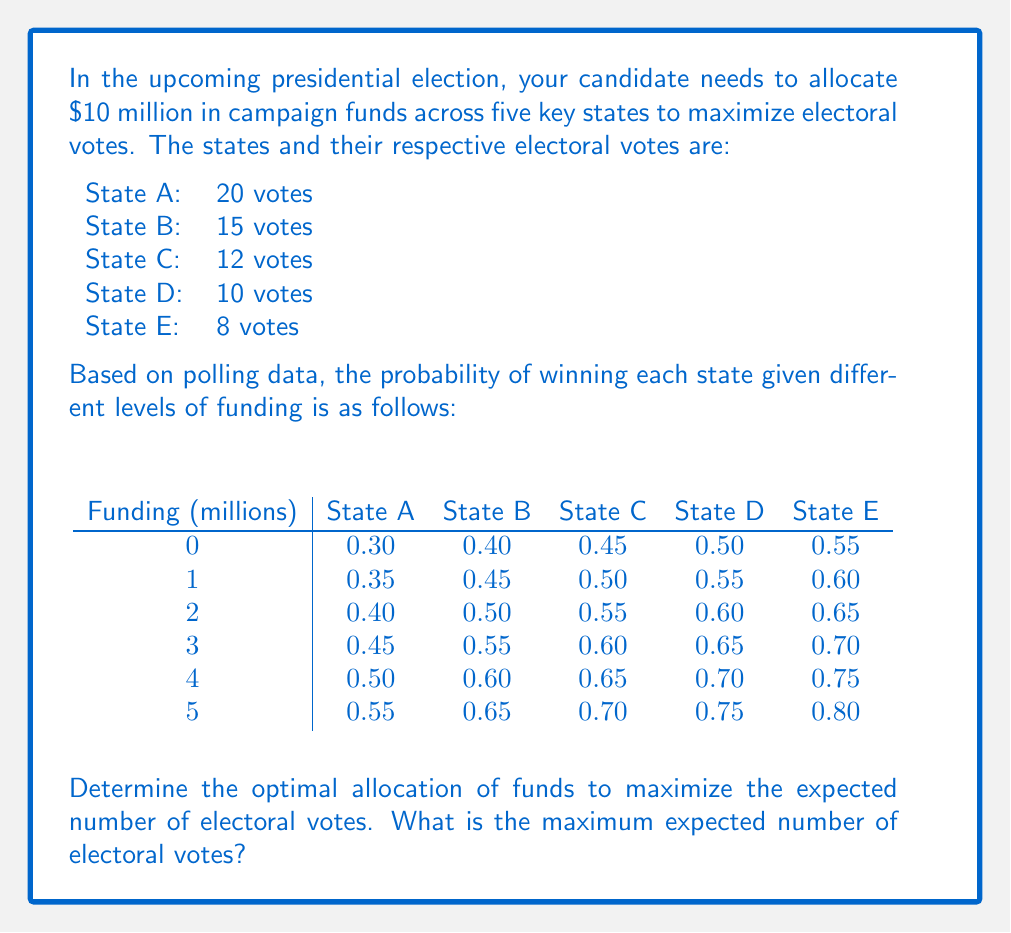Show me your answer to this math problem. To solve this optimization problem, we need to use the concept of expected value and find the combination that maximizes it. Let's approach this step-by-step:

1) First, calculate the expected electoral votes for each state at each funding level:

   Expected votes = (Probability of winning) × (Number of electoral votes)

   For example, for State A with $0 million: 0.30 × 20 = 6 expected votes

2) Create a table of expected votes for each state and funding level:

$$\begin{array}{c|ccccc}
\text{Funding (millions)} & \text{State A} & \text{State B} & \text{State C} & \text{State D} & \text{State E} \\
\hline
0 & 6.00 & 6.00 & 5.40 & 5.00 & 4.40 \\
1 & 7.00 & 6.75 & 6.00 & 5.50 & 4.80 \\
2 & 8.00 & 7.50 & 6.60 & 6.00 & 5.20 \\
3 & 9.00 & 8.25 & 7.20 & 6.50 & 5.60 \\
4 & 10.00 & 9.00 & 7.80 & 7.00 & 6.00 \\
5 & 11.00 & 9.75 & 8.40 & 7.50 & 6.40 \\
\end{array}$$

3) Now, we need to find the combination that maximizes the total expected votes while staying within the $10 million budget.

4) The optimal strategy is to allocate funds to the states where we get the highest marginal benefit (increase in expected votes per million dollars spent).

5) Looking at the table, we can see that the highest marginal benefits are:
   - $5 million to State A (increase of 5 expected votes)
   - $3 million to State B (increase of 2.25 expected votes)
   - $2 million to State C (increase of 1.2 expected votes)

6) This allocation uses all $10 million and gives us the maximum expected votes:

   State A: 11.00
   State B: 8.25
   State C: 6.60
   State D: 5.00 (no funding)
   State E: 4.40 (no funding)

7) The total expected electoral votes is the sum of these: 
   11.00 + 8.25 + 6.60 + 5.00 + 4.40 = 35.25
Answer: The optimal allocation is $5 million to State A, $3 million to State B, and $2 million to State C. The maximum expected number of electoral votes is 35.25. 